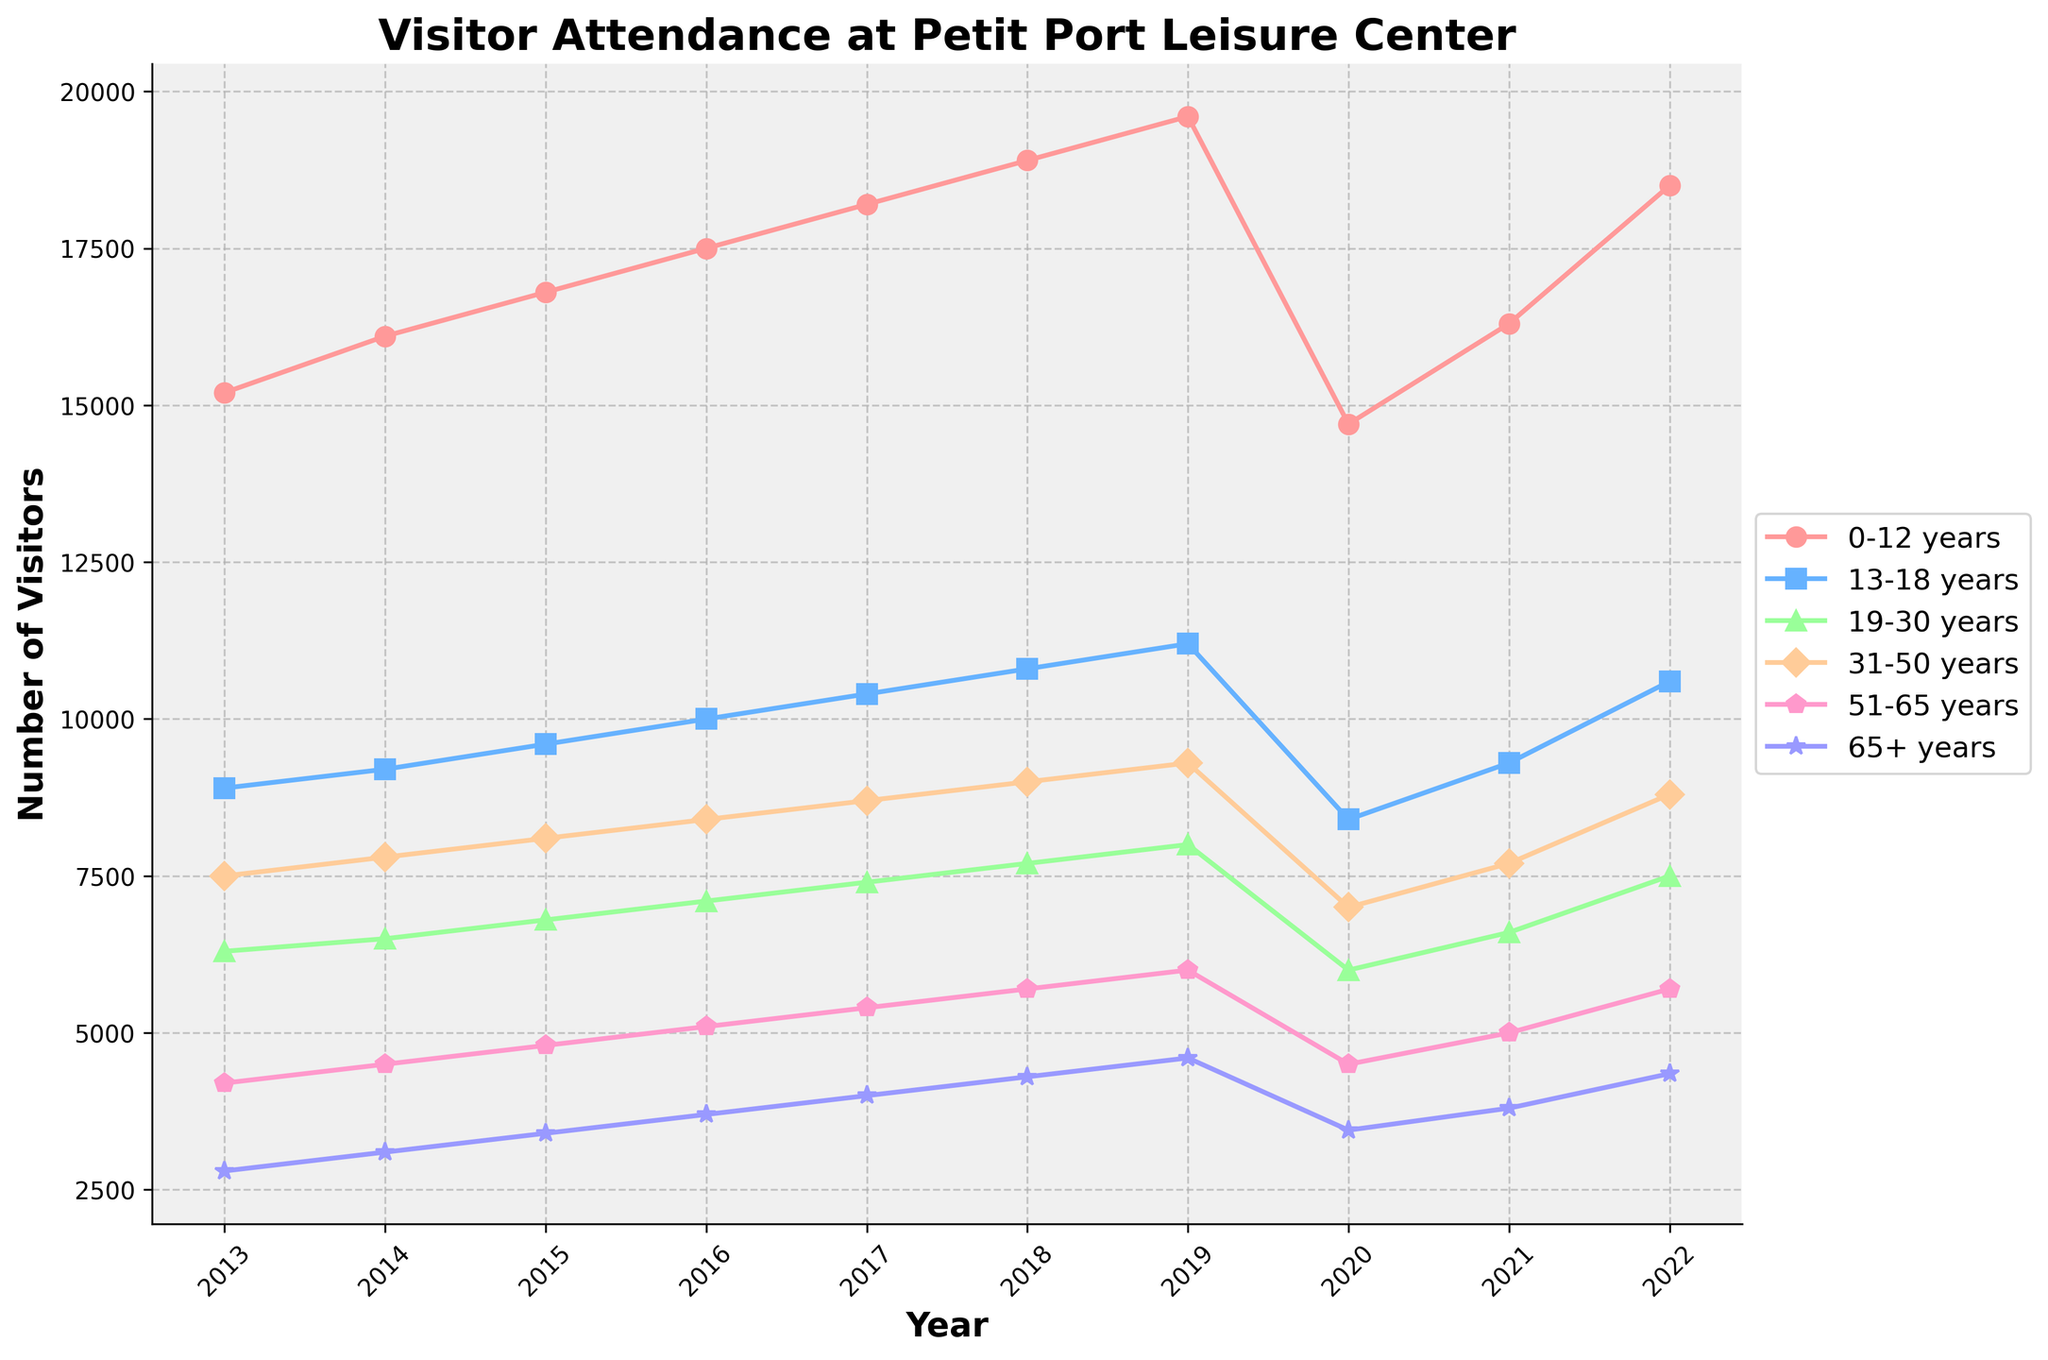What was the highest number of visitors in the 0-12 years age group? Look at the plot for the 0-12 years age group and find the highest point. The highest attendance is in 2019.
Answer: 19600 By how much did the attendance for the 65+ years age group increase from 2013 to 2022? Locate the attendance values for 65+ years in 2013 and 2022. Subtract the value for 2013 from the value for 2022 (4350 - 2800).
Answer: 1550 Which age group had the most visitors in 2017? Identify the data points for all age groups in 2017 and find the one with the highest value. The 0-12 years age group had the highest attendance.
Answer: 0-12 years What is the average attendance for the 31-50 years age group over the given years? Sum the attendance values for the 31-50 years age group from 2013 to 2022 and divide by the number of years. (7500 + 7800 + 8100 + 8400 + 8700 + 9000 + 9300 + 7000 + 7700 + 8800) / 10 = 8130
Answer: 8130 Which age group experienced the most significant drop in attendance in 2020 compared to 2019? For each age group, calculate the difference between attendance in 2019 and 2020 and identify the largest drop. The 0-12 years age group dropped from 19600 in 2019 to 14700 in 2020, which is the largest drop.
Answer: 0-12 years What was the attendance trend for the 19-30 years age group from 2013 to 2022? Observing the plot for the 19-30 years age group from 2013 to 2022, note that it generally increased until 2019, dropped in 2020, and then increased again.
Answer: Increasing, then decreasing, then increasing How many total visitors attended the leisure center in 2016? Sum the attendance numbers for all age groups in 2016. (17500 + 10000 + 7100 + 8400 + 5100 + 3700)
Answer: 51800 In which year did the 51-65 years age group see the highest attendance? Locate the highest point on the plot for the 51-65 years age group and identify the corresponding year.
Answer: 2019 